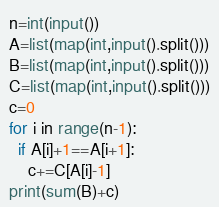<code> <loc_0><loc_0><loc_500><loc_500><_Python_>n=int(input())
A=list(map(int,input().split()))
B=list(map(int,input().split()))
C=list(map(int,input().split()))
c=0
for i in range(n-1):
  if A[i]+1==A[i+1]:
    c+=C[A[i]-1]
print(sum(B)+c)</code> 